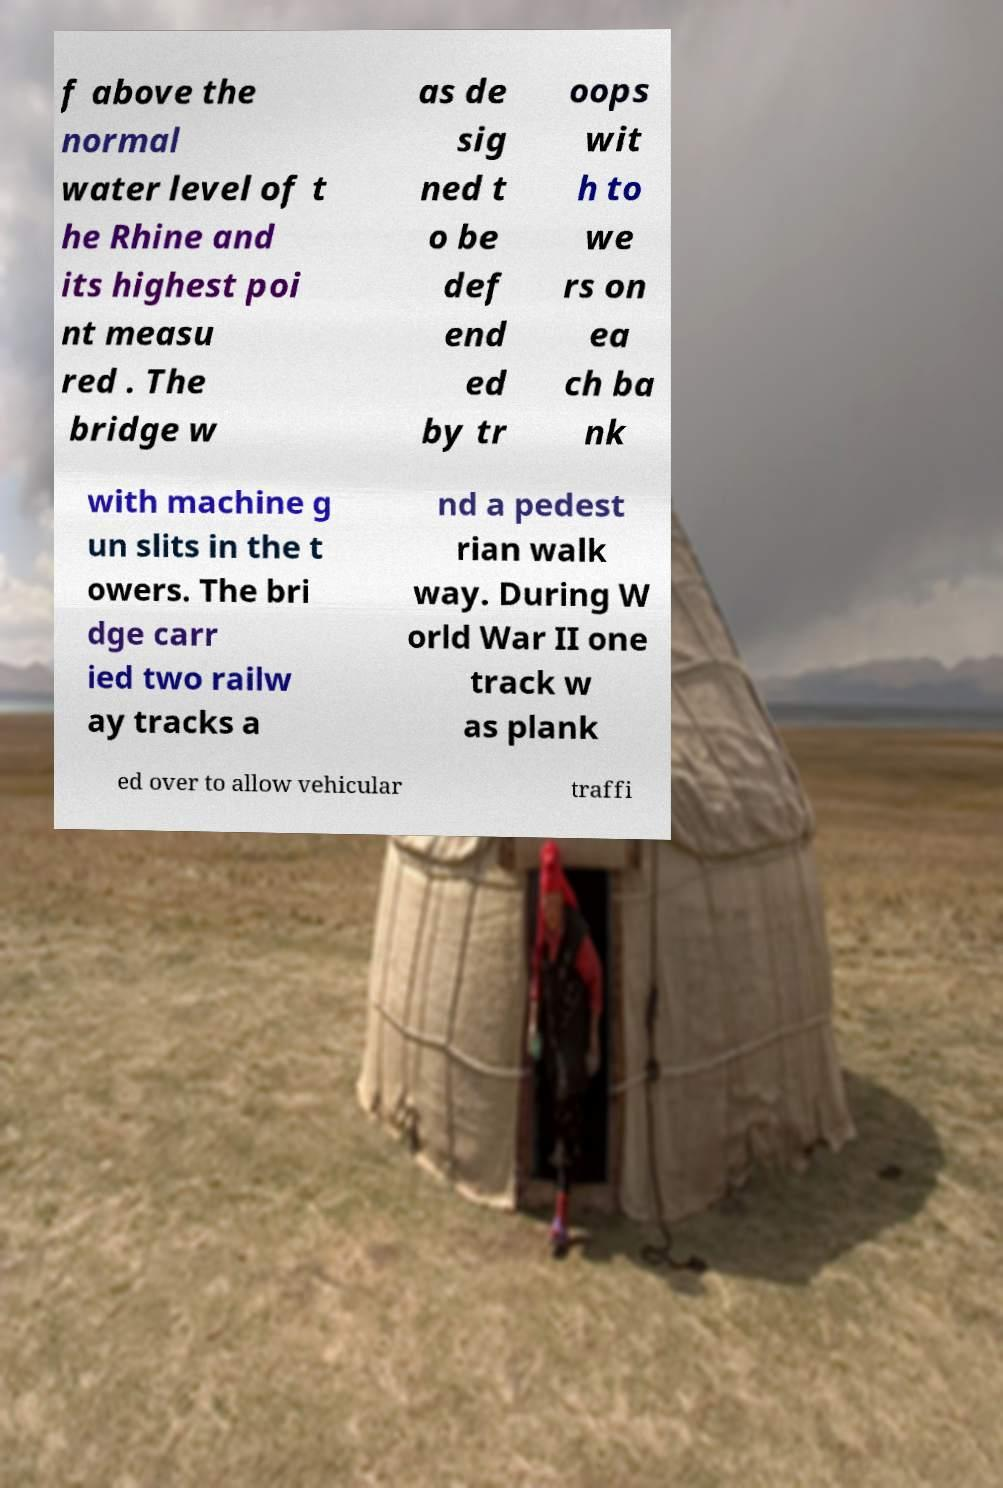Can you accurately transcribe the text from the provided image for me? f above the normal water level of t he Rhine and its highest poi nt measu red . The bridge w as de sig ned t o be def end ed by tr oops wit h to we rs on ea ch ba nk with machine g un slits in the t owers. The bri dge carr ied two railw ay tracks a nd a pedest rian walk way. During W orld War II one track w as plank ed over to allow vehicular traffi 